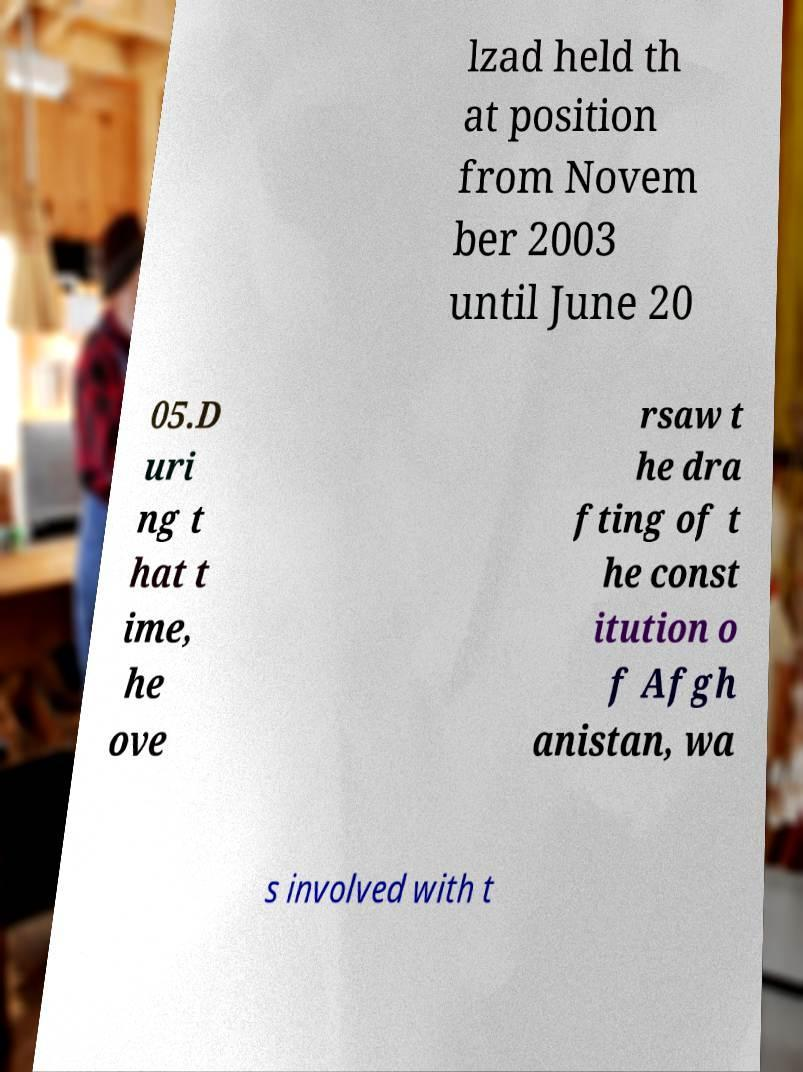Could you extract and type out the text from this image? lzad held th at position from Novem ber 2003 until June 20 05.D uri ng t hat t ime, he ove rsaw t he dra fting of t he const itution o f Afgh anistan, wa s involved with t 